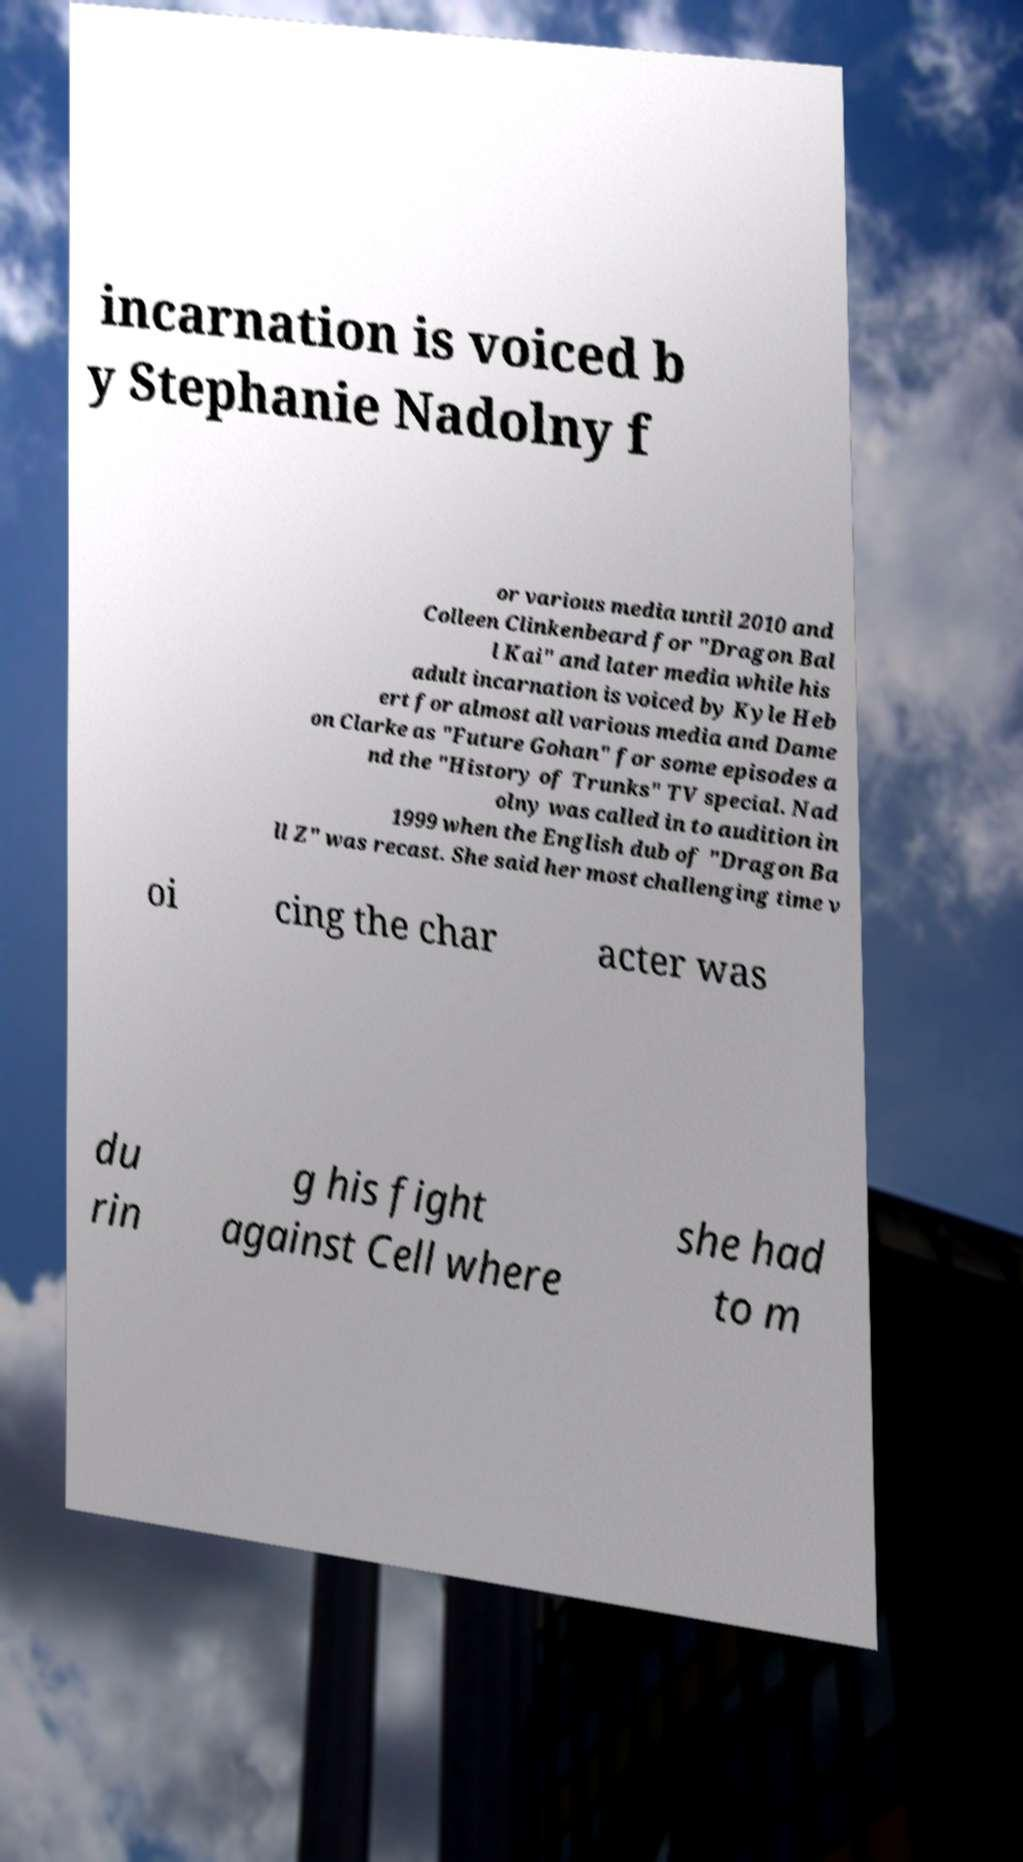Could you assist in decoding the text presented in this image and type it out clearly? incarnation is voiced b y Stephanie Nadolny f or various media until 2010 and Colleen Clinkenbeard for "Dragon Bal l Kai" and later media while his adult incarnation is voiced by Kyle Heb ert for almost all various media and Dame on Clarke as "Future Gohan" for some episodes a nd the "History of Trunks" TV special. Nad olny was called in to audition in 1999 when the English dub of "Dragon Ba ll Z" was recast. She said her most challenging time v oi cing the char acter was du rin g his fight against Cell where she had to m 